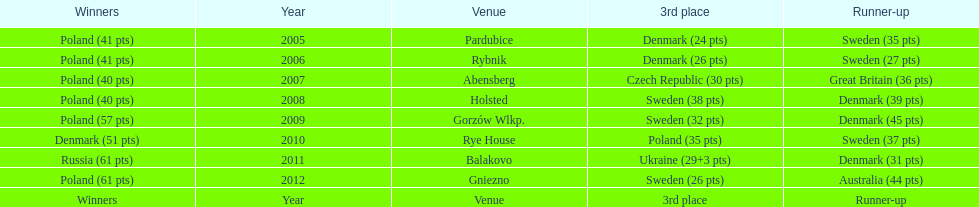What was the difference in final score between russia and denmark in 2011? 30. 